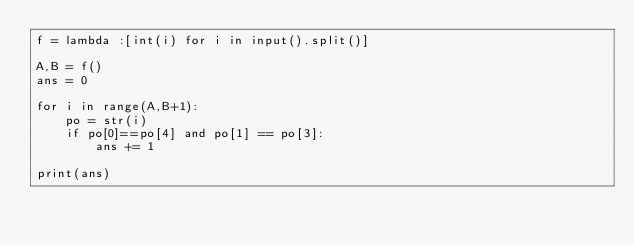<code> <loc_0><loc_0><loc_500><loc_500><_Python_>f = lambda :[int(i) for i in input().split()]

A,B = f()
ans = 0

for i in range(A,B+1):
    po = str(i)
    if po[0]==po[4] and po[1] == po[3]:
        ans += 1
        
print(ans)</code> 